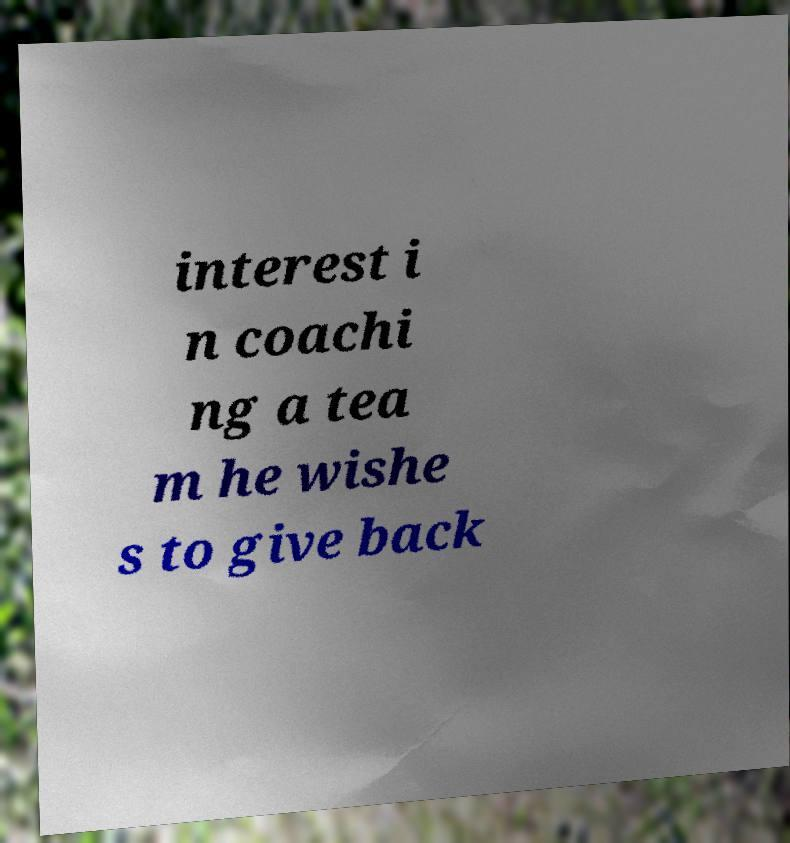Can you accurately transcribe the text from the provided image for me? interest i n coachi ng a tea m he wishe s to give back 